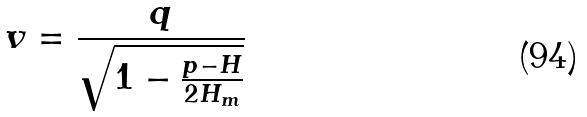<formula> <loc_0><loc_0><loc_500><loc_500>v = \frac { q } { \sqrt { 1 - \frac { p - H } { 2 H _ { m } } } }</formula> 